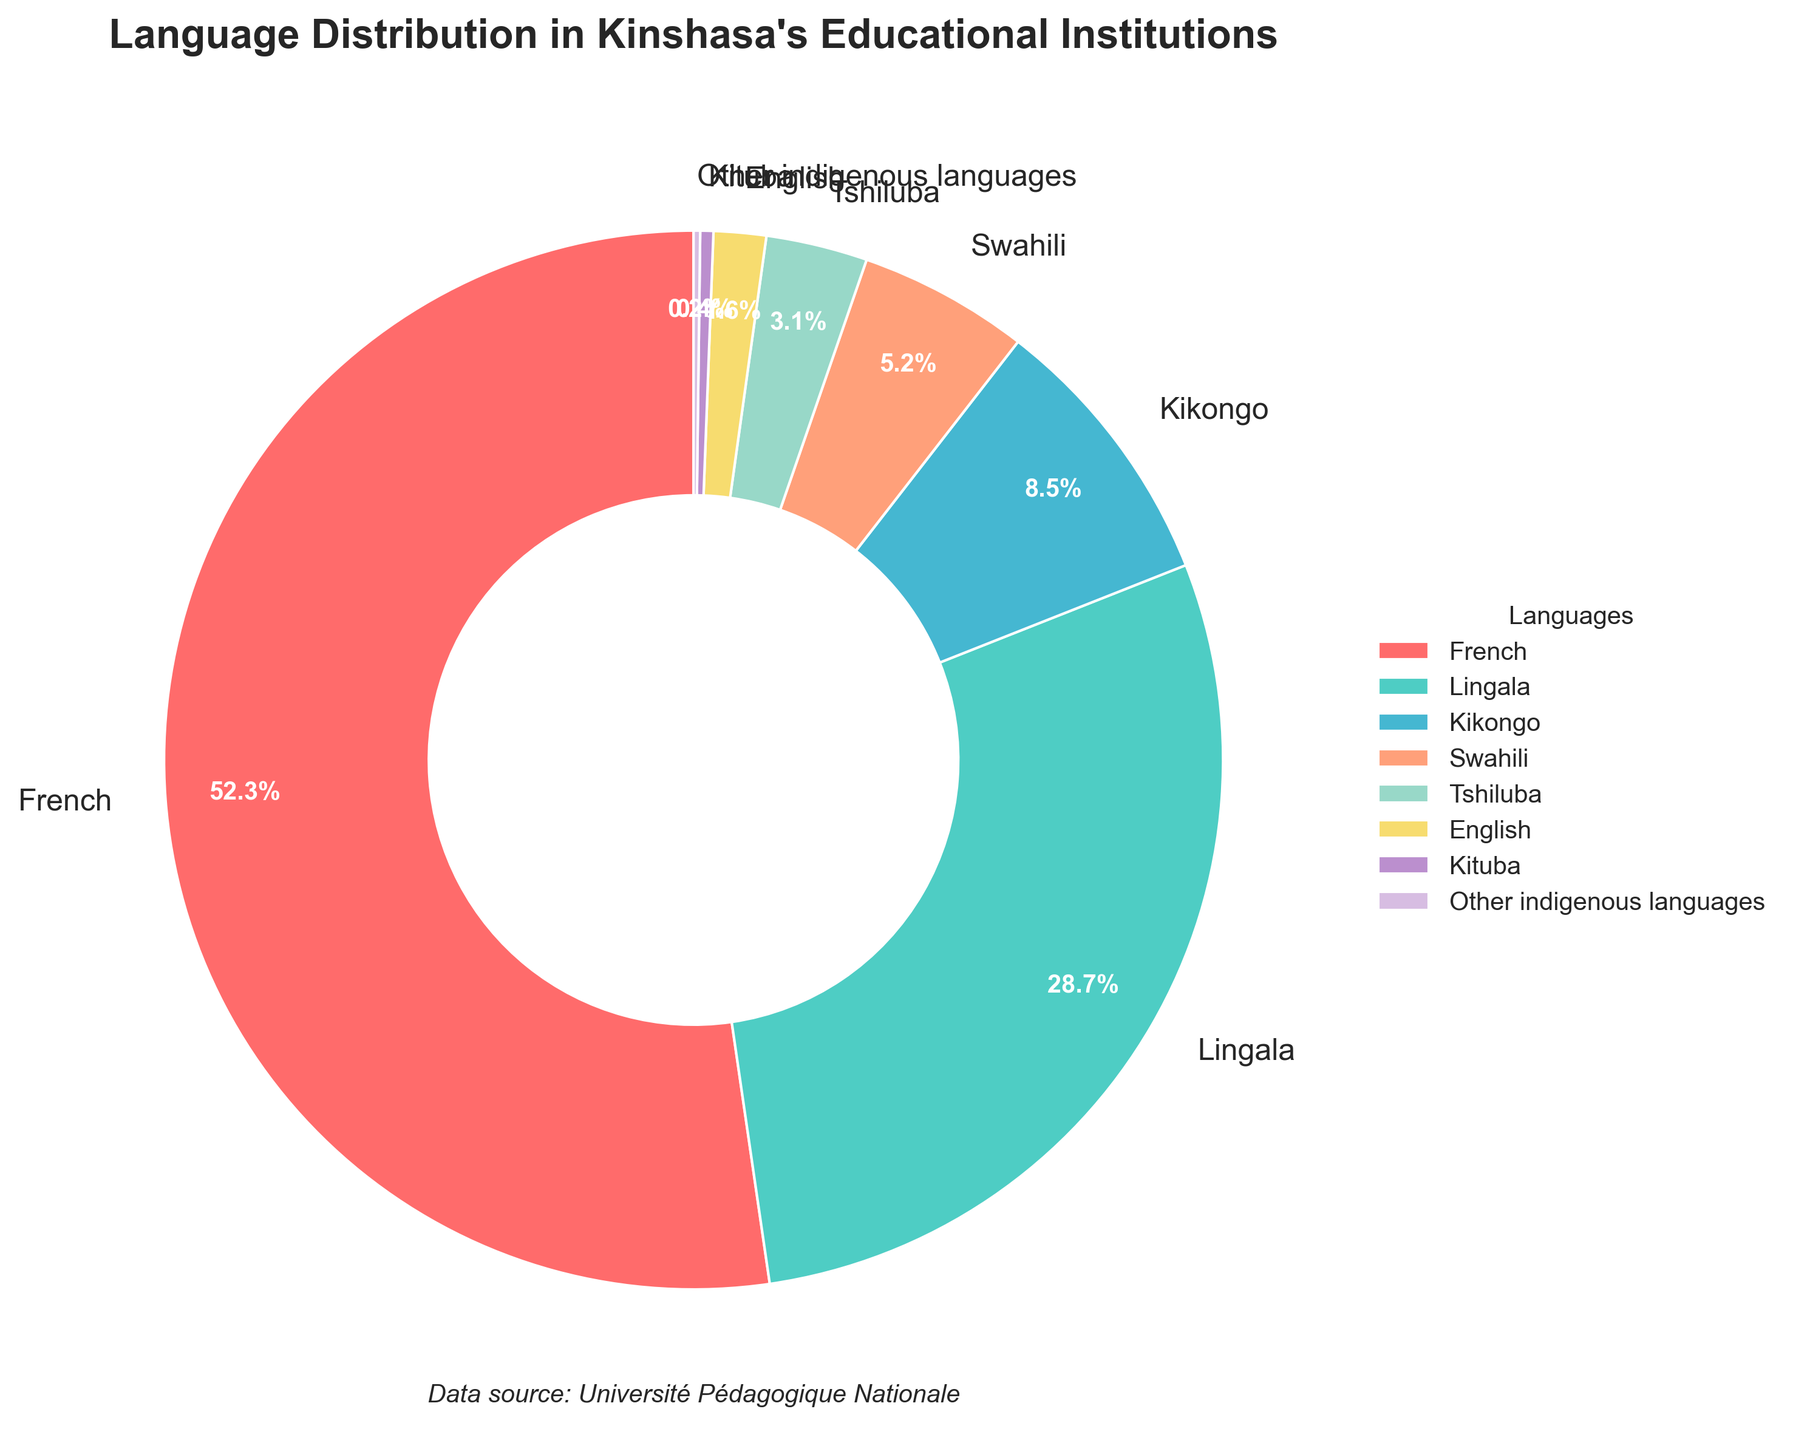what percentage of students speak French? From the pie chart, the sector labeled "French" shows a percentage of 52.3%.
Answer: 52.3% Which languages combined make up for more than 70% of the language distribution? Add the percentages of the languages from the largest until surpassing 70%: French (52.3%) and Lingala (28.7%) together make 81.0%.
Answer: French and Lingala Are there more students who speak Lingala or those who speak Kikongo and Swahili combined? Compare the percentage of Lingala (28.7%) with the combined percentage of Kikongo (8.5%) and Swahili (5.2%), which together total 13.7%. 28.7% is greater than 13.7%.
Answer: Lingala What is the combined percentage of students speaking French, Lingala, and Kikongo? Add the percentages of French (52.3%), Lingala (28.7%), and Kikongo (8.5%). The sum is 89.5%.
Answer: 89.5% Which language has the lowest representation among the students? From the pie chart, the sector with the smallest percentage is "Other indigenous languages" with 0.2%.
Answer: Other indigenous languages What is the total percentage of students speaking either English or Kituba? Add the percentages of English (1.6%) and Kituba (0.4%) to get the total percentage, which is 2.0%.
Answer: 2.0% Which language is represented by the sector with the color red? In the chart, the color red is used for the "French" sector.
Answer: French How many languages make up less than 2% of the spoken languages? From the chart, the languages that make up less than 2% are English (1.6%), Kituba (0.4%), and Other indigenous languages (0.2%). These are in total 3 languages.
Answer: 3 